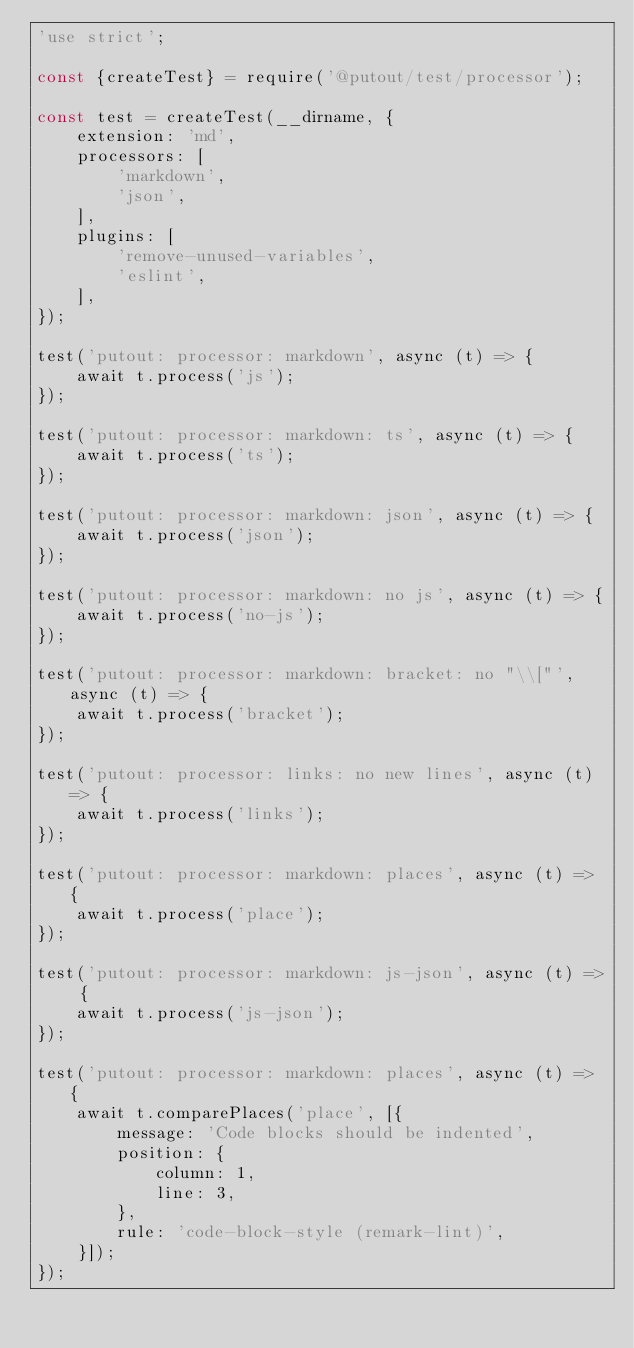Convert code to text. <code><loc_0><loc_0><loc_500><loc_500><_JavaScript_>'use strict';

const {createTest} = require('@putout/test/processor');

const test = createTest(__dirname, {
    extension: 'md',
    processors: [
        'markdown',
        'json',
    ],
    plugins: [
        'remove-unused-variables',
        'eslint',
    ],
});

test('putout: processor: markdown', async (t) => {
    await t.process('js');
});

test('putout: processor: markdown: ts', async (t) => {
    await t.process('ts');
});

test('putout: processor: markdown: json', async (t) => {
    await t.process('json');
});

test('putout: processor: markdown: no js', async (t) => {
    await t.process('no-js');
});

test('putout: processor: markdown: bracket: no "\\["', async (t) => {
    await t.process('bracket');
});

test('putout: processor: links: no new lines', async (t) => {
    await t.process('links');
});

test('putout: processor: markdown: places', async (t) => {
    await t.process('place');
});

test('putout: processor: markdown: js-json', async (t) => {
    await t.process('js-json');
});

test('putout: processor: markdown: places', async (t) => {
    await t.comparePlaces('place', [{
        message: 'Code blocks should be indented',
        position: {
            column: 1,
            line: 3,
        },
        rule: 'code-block-style (remark-lint)',
    }]);
});

</code> 